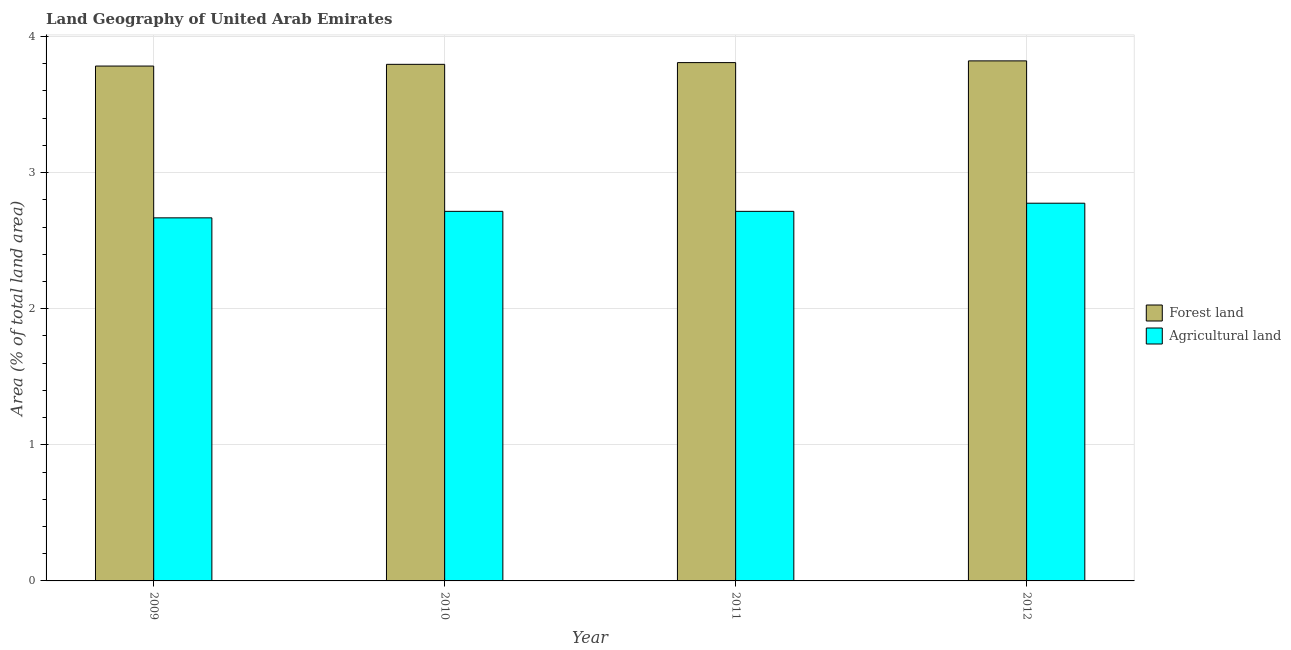How many different coloured bars are there?
Your answer should be very brief. 2. How many bars are there on the 4th tick from the left?
Keep it short and to the point. 2. What is the percentage of land area under forests in 2011?
Your response must be concise. 3.81. Across all years, what is the maximum percentage of land area under forests?
Keep it short and to the point. 3.82. Across all years, what is the minimum percentage of land area under agriculture?
Provide a succinct answer. 2.67. In which year was the percentage of land area under agriculture maximum?
Ensure brevity in your answer.  2012. What is the total percentage of land area under forests in the graph?
Offer a very short reply. 15.21. What is the difference between the percentage of land area under forests in 2010 and that in 2011?
Offer a very short reply. -0.01. What is the difference between the percentage of land area under forests in 2011 and the percentage of land area under agriculture in 2012?
Offer a terse response. -0.01. What is the average percentage of land area under forests per year?
Offer a very short reply. 3.8. In the year 2012, what is the difference between the percentage of land area under agriculture and percentage of land area under forests?
Your answer should be very brief. 0. In how many years, is the percentage of land area under agriculture greater than 1.2 %?
Offer a terse response. 4. What is the ratio of the percentage of land area under forests in 2010 to that in 2011?
Make the answer very short. 1. Is the percentage of land area under forests in 2009 less than that in 2011?
Provide a succinct answer. Yes. Is the difference between the percentage of land area under agriculture in 2010 and 2012 greater than the difference between the percentage of land area under forests in 2010 and 2012?
Your answer should be compact. No. What is the difference between the highest and the second highest percentage of land area under agriculture?
Provide a short and direct response. 0.06. What is the difference between the highest and the lowest percentage of land area under forests?
Your answer should be very brief. 0.04. In how many years, is the percentage of land area under agriculture greater than the average percentage of land area under agriculture taken over all years?
Give a very brief answer. 1. Is the sum of the percentage of land area under forests in 2011 and 2012 greater than the maximum percentage of land area under agriculture across all years?
Offer a very short reply. Yes. What does the 2nd bar from the left in 2011 represents?
Give a very brief answer. Agricultural land. What does the 1st bar from the right in 2009 represents?
Ensure brevity in your answer.  Agricultural land. How many bars are there?
Provide a short and direct response. 8. Are all the bars in the graph horizontal?
Make the answer very short. No. How many years are there in the graph?
Your answer should be very brief. 4. Are the values on the major ticks of Y-axis written in scientific E-notation?
Your response must be concise. No. Does the graph contain grids?
Your answer should be compact. Yes. Where does the legend appear in the graph?
Your answer should be very brief. Center right. How many legend labels are there?
Keep it short and to the point. 2. How are the legend labels stacked?
Provide a short and direct response. Vertical. What is the title of the graph?
Offer a terse response. Land Geography of United Arab Emirates. What is the label or title of the X-axis?
Ensure brevity in your answer.  Year. What is the label or title of the Y-axis?
Your answer should be very brief. Area (% of total land area). What is the Area (% of total land area) in Forest land in 2009?
Offer a terse response. 3.78. What is the Area (% of total land area) in Agricultural land in 2009?
Provide a succinct answer. 2.67. What is the Area (% of total land area) of Forest land in 2010?
Provide a succinct answer. 3.8. What is the Area (% of total land area) of Agricultural land in 2010?
Make the answer very short. 2.72. What is the Area (% of total land area) of Forest land in 2011?
Keep it short and to the point. 3.81. What is the Area (% of total land area) in Agricultural land in 2011?
Provide a short and direct response. 2.72. What is the Area (% of total land area) of Forest land in 2012?
Your response must be concise. 3.82. What is the Area (% of total land area) in Agricultural land in 2012?
Provide a short and direct response. 2.78. Across all years, what is the maximum Area (% of total land area) of Forest land?
Offer a terse response. 3.82. Across all years, what is the maximum Area (% of total land area) in Agricultural land?
Provide a short and direct response. 2.78. Across all years, what is the minimum Area (% of total land area) of Forest land?
Make the answer very short. 3.78. Across all years, what is the minimum Area (% of total land area) of Agricultural land?
Keep it short and to the point. 2.67. What is the total Area (% of total land area) in Forest land in the graph?
Your answer should be very brief. 15.21. What is the total Area (% of total land area) of Agricultural land in the graph?
Make the answer very short. 10.87. What is the difference between the Area (% of total land area) in Forest land in 2009 and that in 2010?
Ensure brevity in your answer.  -0.01. What is the difference between the Area (% of total land area) in Agricultural land in 2009 and that in 2010?
Your answer should be very brief. -0.05. What is the difference between the Area (% of total land area) of Forest land in 2009 and that in 2011?
Provide a succinct answer. -0.03. What is the difference between the Area (% of total land area) of Agricultural land in 2009 and that in 2011?
Give a very brief answer. -0.05. What is the difference between the Area (% of total land area) in Forest land in 2009 and that in 2012?
Ensure brevity in your answer.  -0.04. What is the difference between the Area (% of total land area) in Agricultural land in 2009 and that in 2012?
Ensure brevity in your answer.  -0.11. What is the difference between the Area (% of total land area) of Forest land in 2010 and that in 2011?
Your answer should be compact. -0.01. What is the difference between the Area (% of total land area) in Agricultural land in 2010 and that in 2011?
Your response must be concise. 0. What is the difference between the Area (% of total land area) of Forest land in 2010 and that in 2012?
Provide a short and direct response. -0.03. What is the difference between the Area (% of total land area) of Agricultural land in 2010 and that in 2012?
Provide a short and direct response. -0.06. What is the difference between the Area (% of total land area) in Forest land in 2011 and that in 2012?
Offer a very short reply. -0.01. What is the difference between the Area (% of total land area) of Agricultural land in 2011 and that in 2012?
Keep it short and to the point. -0.06. What is the difference between the Area (% of total land area) of Forest land in 2009 and the Area (% of total land area) of Agricultural land in 2010?
Offer a terse response. 1.07. What is the difference between the Area (% of total land area) of Forest land in 2009 and the Area (% of total land area) of Agricultural land in 2011?
Give a very brief answer. 1.07. What is the difference between the Area (% of total land area) in Forest land in 2009 and the Area (% of total land area) in Agricultural land in 2012?
Provide a short and direct response. 1.01. What is the difference between the Area (% of total land area) in Forest land in 2010 and the Area (% of total land area) in Agricultural land in 2011?
Provide a succinct answer. 1.08. What is the difference between the Area (% of total land area) in Forest land in 2010 and the Area (% of total land area) in Agricultural land in 2012?
Your answer should be compact. 1.02. What is the difference between the Area (% of total land area) of Forest land in 2011 and the Area (% of total land area) of Agricultural land in 2012?
Your response must be concise. 1.03. What is the average Area (% of total land area) in Forest land per year?
Provide a succinct answer. 3.8. What is the average Area (% of total land area) of Agricultural land per year?
Make the answer very short. 2.72. In the year 2009, what is the difference between the Area (% of total land area) in Forest land and Area (% of total land area) in Agricultural land?
Keep it short and to the point. 1.12. In the year 2010, what is the difference between the Area (% of total land area) in Forest land and Area (% of total land area) in Agricultural land?
Provide a short and direct response. 1.08. In the year 2011, what is the difference between the Area (% of total land area) of Forest land and Area (% of total land area) of Agricultural land?
Offer a very short reply. 1.09. In the year 2012, what is the difference between the Area (% of total land area) of Forest land and Area (% of total land area) of Agricultural land?
Your answer should be compact. 1.05. What is the ratio of the Area (% of total land area) in Agricultural land in 2009 to that in 2010?
Provide a short and direct response. 0.98. What is the ratio of the Area (% of total land area) of Agricultural land in 2009 to that in 2011?
Your answer should be very brief. 0.98. What is the ratio of the Area (% of total land area) in Agricultural land in 2009 to that in 2012?
Keep it short and to the point. 0.96. What is the ratio of the Area (% of total land area) of Forest land in 2010 to that in 2011?
Your response must be concise. 1. What is the ratio of the Area (% of total land area) in Forest land in 2010 to that in 2012?
Give a very brief answer. 0.99. What is the ratio of the Area (% of total land area) of Agricultural land in 2010 to that in 2012?
Offer a very short reply. 0.98. What is the ratio of the Area (% of total land area) of Forest land in 2011 to that in 2012?
Ensure brevity in your answer.  1. What is the ratio of the Area (% of total land area) in Agricultural land in 2011 to that in 2012?
Your answer should be compact. 0.98. What is the difference between the highest and the second highest Area (% of total land area) of Forest land?
Your answer should be very brief. 0.01. What is the difference between the highest and the second highest Area (% of total land area) in Agricultural land?
Keep it short and to the point. 0.06. What is the difference between the highest and the lowest Area (% of total land area) in Forest land?
Ensure brevity in your answer.  0.04. What is the difference between the highest and the lowest Area (% of total land area) in Agricultural land?
Offer a terse response. 0.11. 